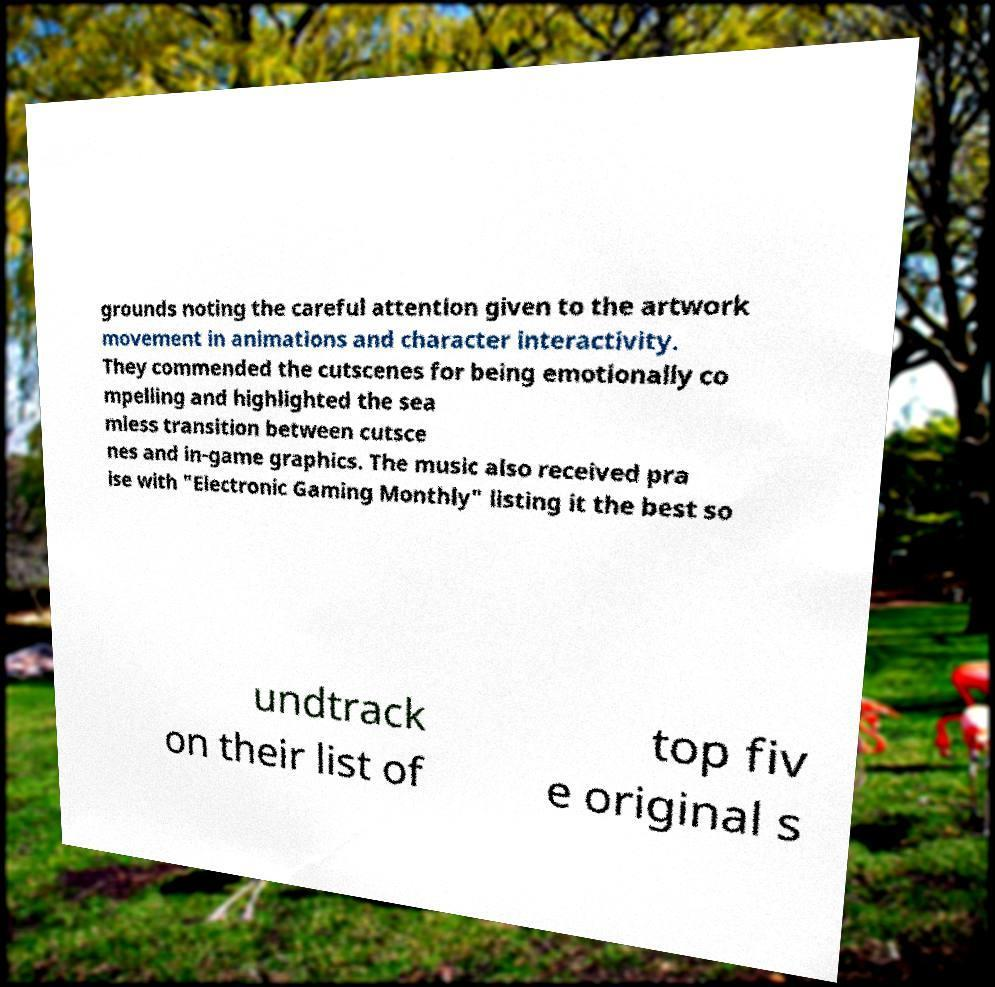Please read and relay the text visible in this image. What does it say? grounds noting the careful attention given to the artwork movement in animations and character interactivity. They commended the cutscenes for being emotionally co mpelling and highlighted the sea mless transition between cutsce nes and in-game graphics. The music also received pra ise with "Electronic Gaming Monthly" listing it the best so undtrack on their list of top fiv e original s 